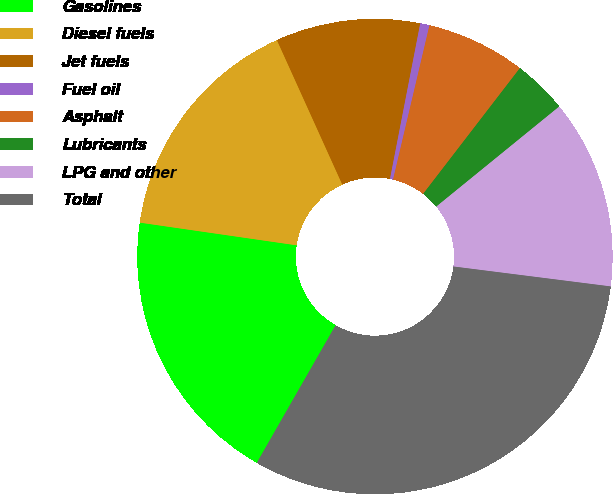<chart> <loc_0><loc_0><loc_500><loc_500><pie_chart><fcel>Gasolines<fcel>Diesel fuels<fcel>Jet fuels<fcel>Fuel oil<fcel>Asphalt<fcel>Lubricants<fcel>LPG and other<fcel>Total<nl><fcel>19.01%<fcel>15.95%<fcel>9.82%<fcel>0.63%<fcel>6.75%<fcel>3.69%<fcel>12.88%<fcel>31.27%<nl></chart> 